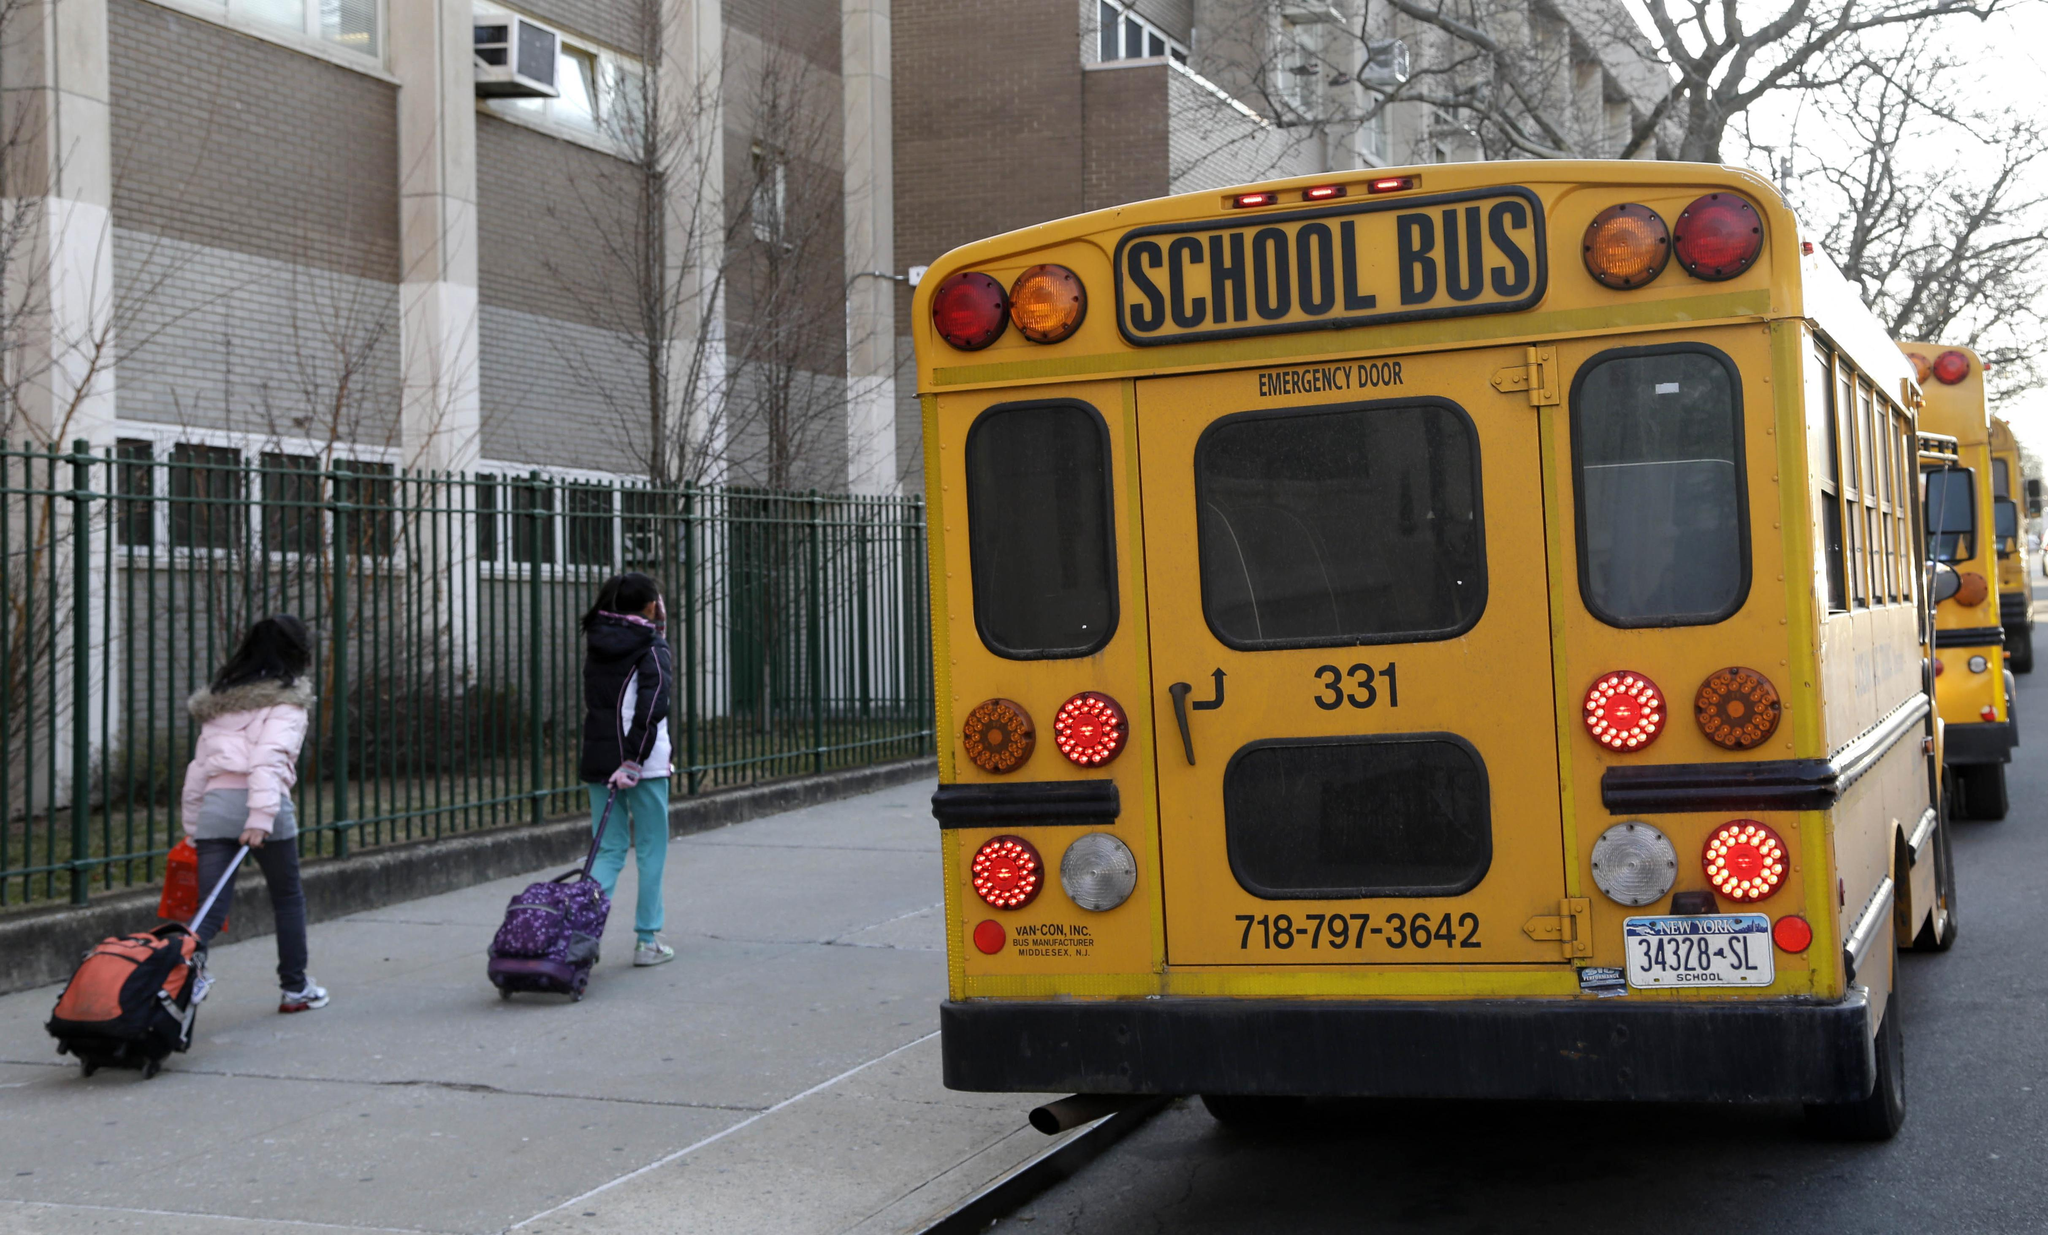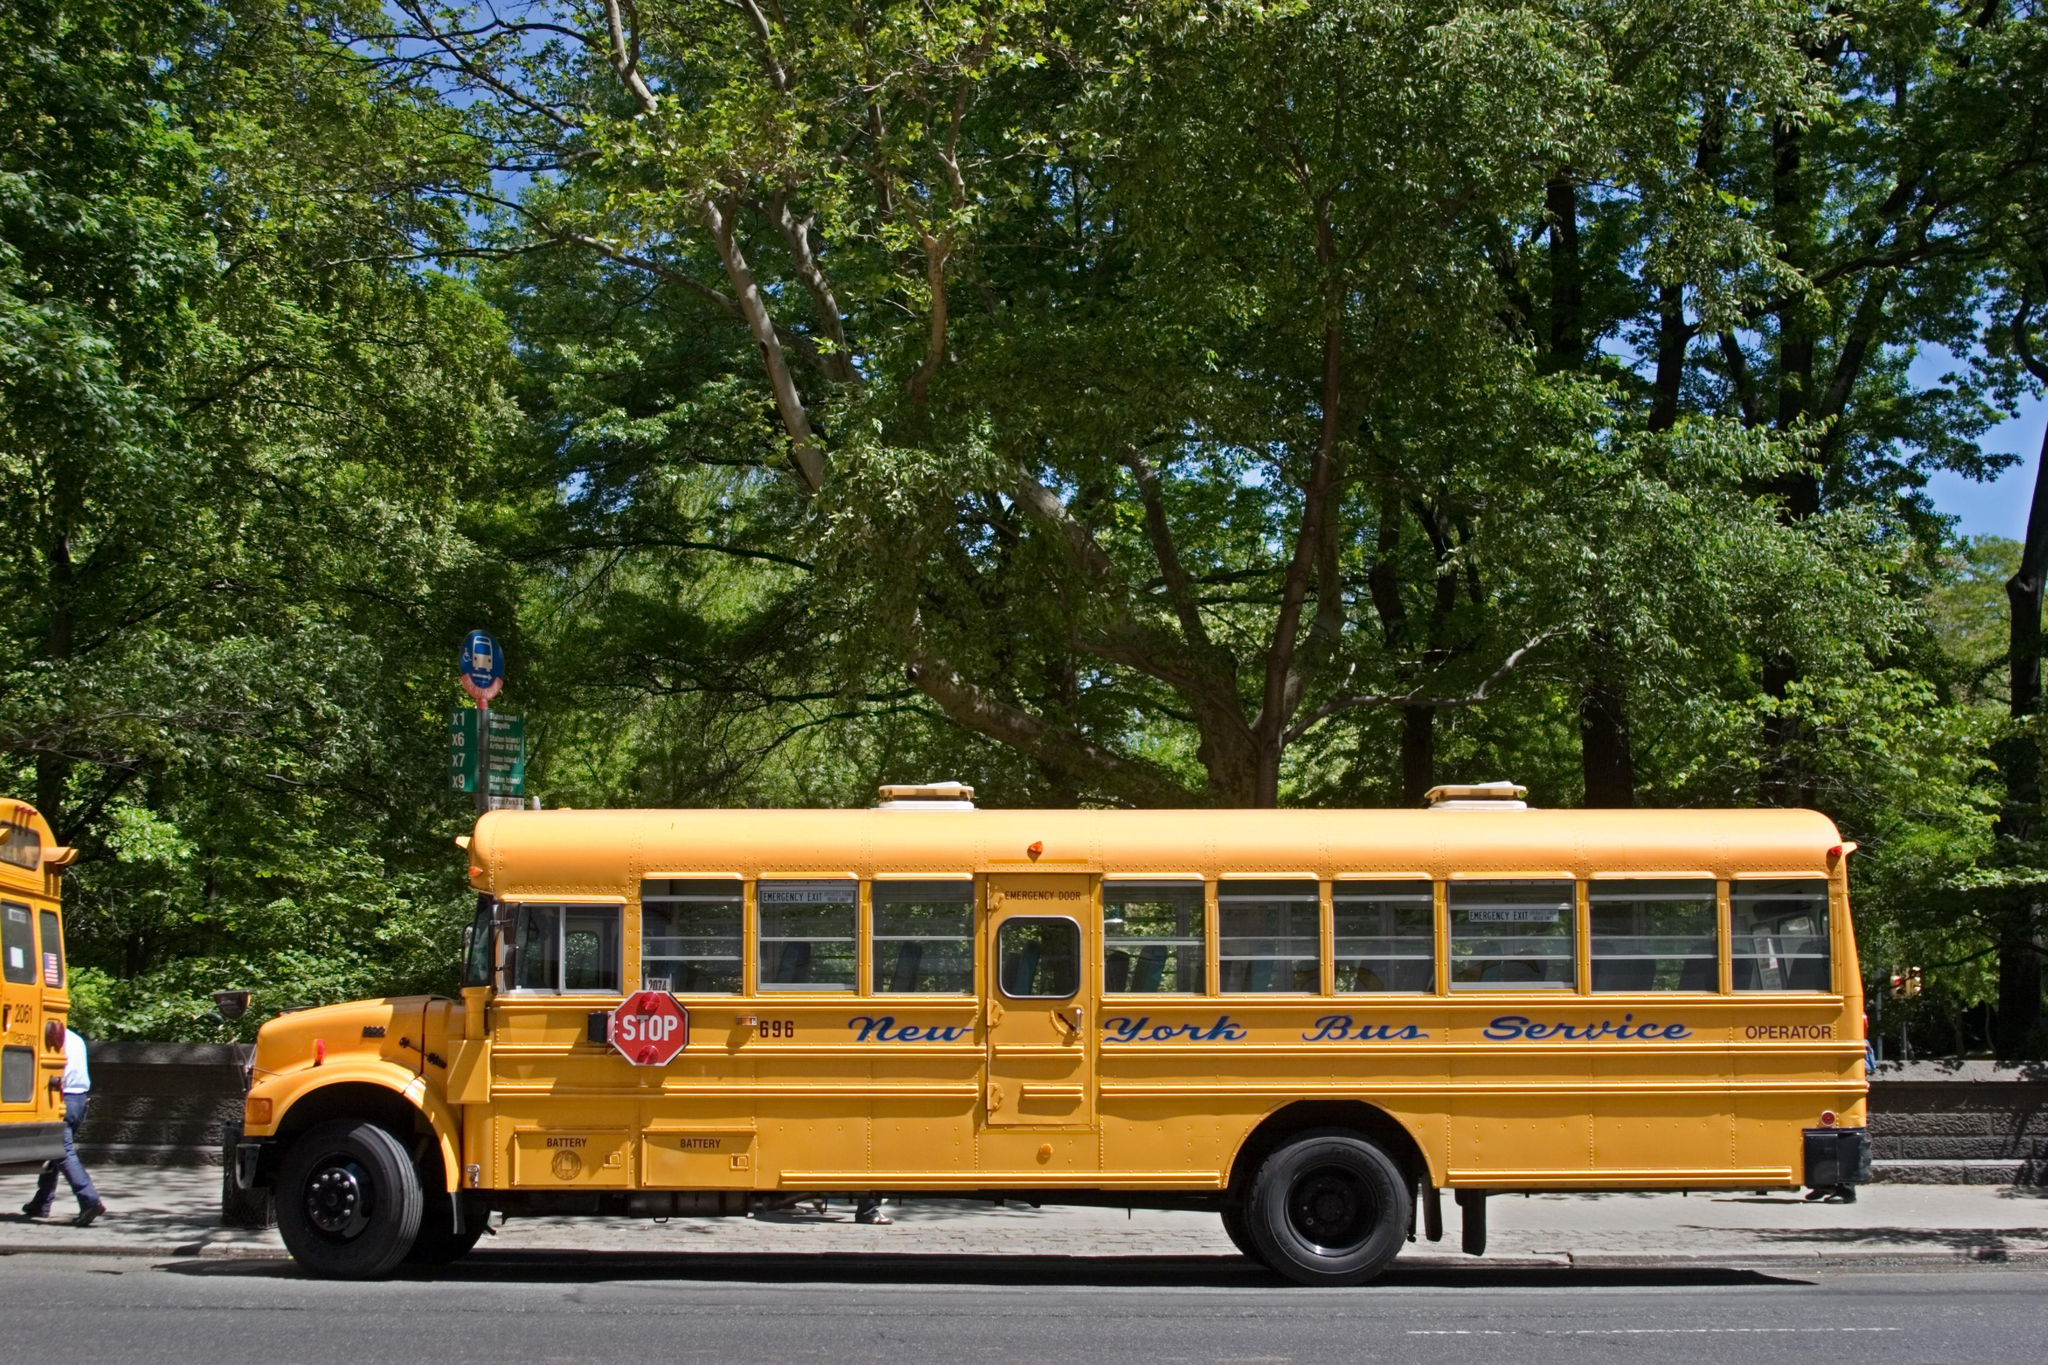The first image is the image on the left, the second image is the image on the right. Considering the images on both sides, is "One image shows a short leftward headed non-flat school bus with no more than five passenger windows per side, and the other image shows a short rightward angled bus from the rear." valid? Answer yes or no. No. The first image is the image on the left, the second image is the image on the right. Considering the images on both sides, is "There are exactly two school buses." valid? Answer yes or no. No. 